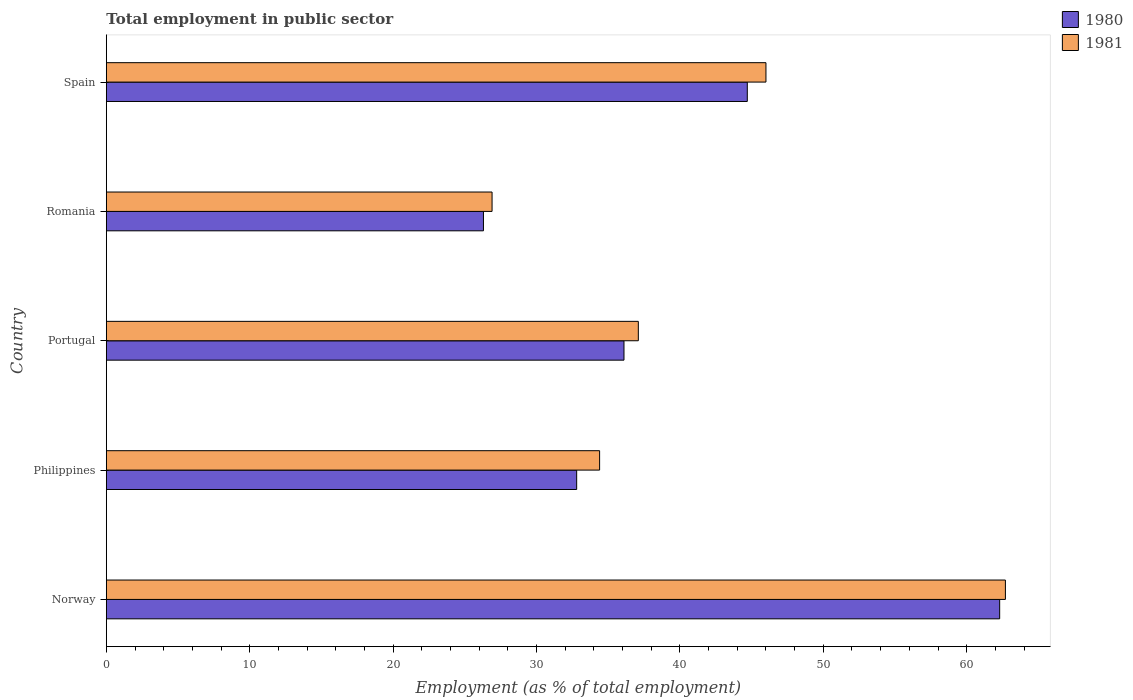How many different coloured bars are there?
Offer a terse response. 2. How many groups of bars are there?
Your answer should be very brief. 5. In how many cases, is the number of bars for a given country not equal to the number of legend labels?
Ensure brevity in your answer.  0. What is the employment in public sector in 1980 in Romania?
Your response must be concise. 26.3. Across all countries, what is the maximum employment in public sector in 1980?
Your answer should be very brief. 62.3. Across all countries, what is the minimum employment in public sector in 1980?
Offer a very short reply. 26.3. In which country was the employment in public sector in 1980 maximum?
Your response must be concise. Norway. In which country was the employment in public sector in 1980 minimum?
Give a very brief answer. Romania. What is the total employment in public sector in 1980 in the graph?
Ensure brevity in your answer.  202.2. What is the difference between the employment in public sector in 1980 in Portugal and that in Romania?
Offer a terse response. 9.8. What is the difference between the employment in public sector in 1980 in Spain and the employment in public sector in 1981 in Romania?
Your response must be concise. 17.8. What is the average employment in public sector in 1980 per country?
Give a very brief answer. 40.44. What is the difference between the employment in public sector in 1981 and employment in public sector in 1980 in Philippines?
Provide a succinct answer. 1.6. In how many countries, is the employment in public sector in 1980 greater than 34 %?
Keep it short and to the point. 3. What is the ratio of the employment in public sector in 1981 in Norway to that in Spain?
Provide a succinct answer. 1.36. Is the employment in public sector in 1981 in Philippines less than that in Romania?
Ensure brevity in your answer.  No. What is the difference between the highest and the second highest employment in public sector in 1980?
Your response must be concise. 17.6. What is the difference between the highest and the lowest employment in public sector in 1980?
Keep it short and to the point. 36. In how many countries, is the employment in public sector in 1981 greater than the average employment in public sector in 1981 taken over all countries?
Offer a terse response. 2. How many countries are there in the graph?
Your answer should be very brief. 5. Does the graph contain grids?
Your response must be concise. No. How are the legend labels stacked?
Make the answer very short. Vertical. What is the title of the graph?
Provide a short and direct response. Total employment in public sector. Does "1980" appear as one of the legend labels in the graph?
Provide a short and direct response. Yes. What is the label or title of the X-axis?
Provide a succinct answer. Employment (as % of total employment). What is the label or title of the Y-axis?
Your response must be concise. Country. What is the Employment (as % of total employment) in 1980 in Norway?
Your answer should be compact. 62.3. What is the Employment (as % of total employment) in 1981 in Norway?
Ensure brevity in your answer.  62.7. What is the Employment (as % of total employment) of 1980 in Philippines?
Provide a succinct answer. 32.8. What is the Employment (as % of total employment) of 1981 in Philippines?
Offer a terse response. 34.4. What is the Employment (as % of total employment) of 1980 in Portugal?
Make the answer very short. 36.1. What is the Employment (as % of total employment) in 1981 in Portugal?
Your response must be concise. 37.1. What is the Employment (as % of total employment) of 1980 in Romania?
Give a very brief answer. 26.3. What is the Employment (as % of total employment) in 1981 in Romania?
Offer a very short reply. 26.9. What is the Employment (as % of total employment) of 1980 in Spain?
Offer a terse response. 44.7. Across all countries, what is the maximum Employment (as % of total employment) of 1980?
Provide a succinct answer. 62.3. Across all countries, what is the maximum Employment (as % of total employment) in 1981?
Ensure brevity in your answer.  62.7. Across all countries, what is the minimum Employment (as % of total employment) of 1980?
Make the answer very short. 26.3. Across all countries, what is the minimum Employment (as % of total employment) of 1981?
Make the answer very short. 26.9. What is the total Employment (as % of total employment) of 1980 in the graph?
Your answer should be very brief. 202.2. What is the total Employment (as % of total employment) of 1981 in the graph?
Offer a very short reply. 207.1. What is the difference between the Employment (as % of total employment) of 1980 in Norway and that in Philippines?
Provide a succinct answer. 29.5. What is the difference between the Employment (as % of total employment) in 1981 in Norway and that in Philippines?
Your response must be concise. 28.3. What is the difference between the Employment (as % of total employment) of 1980 in Norway and that in Portugal?
Your response must be concise. 26.2. What is the difference between the Employment (as % of total employment) in 1981 in Norway and that in Portugal?
Make the answer very short. 25.6. What is the difference between the Employment (as % of total employment) in 1981 in Norway and that in Romania?
Make the answer very short. 35.8. What is the difference between the Employment (as % of total employment) in 1981 in Norway and that in Spain?
Ensure brevity in your answer.  16.7. What is the difference between the Employment (as % of total employment) in 1980 in Philippines and that in Portugal?
Offer a terse response. -3.3. What is the difference between the Employment (as % of total employment) in 1981 in Philippines and that in Portugal?
Give a very brief answer. -2.7. What is the difference between the Employment (as % of total employment) in 1980 in Philippines and that in Romania?
Your answer should be very brief. 6.5. What is the difference between the Employment (as % of total employment) in 1981 in Philippines and that in Romania?
Your answer should be very brief. 7.5. What is the difference between the Employment (as % of total employment) in 1981 in Philippines and that in Spain?
Offer a terse response. -11.6. What is the difference between the Employment (as % of total employment) in 1981 in Portugal and that in Romania?
Provide a succinct answer. 10.2. What is the difference between the Employment (as % of total employment) of 1980 in Portugal and that in Spain?
Your answer should be compact. -8.6. What is the difference between the Employment (as % of total employment) in 1981 in Portugal and that in Spain?
Your answer should be very brief. -8.9. What is the difference between the Employment (as % of total employment) of 1980 in Romania and that in Spain?
Keep it short and to the point. -18.4. What is the difference between the Employment (as % of total employment) of 1981 in Romania and that in Spain?
Make the answer very short. -19.1. What is the difference between the Employment (as % of total employment) in 1980 in Norway and the Employment (as % of total employment) in 1981 in Philippines?
Your response must be concise. 27.9. What is the difference between the Employment (as % of total employment) of 1980 in Norway and the Employment (as % of total employment) of 1981 in Portugal?
Offer a terse response. 25.2. What is the difference between the Employment (as % of total employment) of 1980 in Norway and the Employment (as % of total employment) of 1981 in Romania?
Your answer should be very brief. 35.4. What is the difference between the Employment (as % of total employment) in 1980 in Philippines and the Employment (as % of total employment) in 1981 in Romania?
Ensure brevity in your answer.  5.9. What is the difference between the Employment (as % of total employment) of 1980 in Philippines and the Employment (as % of total employment) of 1981 in Spain?
Give a very brief answer. -13.2. What is the difference between the Employment (as % of total employment) of 1980 in Portugal and the Employment (as % of total employment) of 1981 in Romania?
Give a very brief answer. 9.2. What is the difference between the Employment (as % of total employment) in 1980 in Portugal and the Employment (as % of total employment) in 1981 in Spain?
Keep it short and to the point. -9.9. What is the difference between the Employment (as % of total employment) of 1980 in Romania and the Employment (as % of total employment) of 1981 in Spain?
Make the answer very short. -19.7. What is the average Employment (as % of total employment) of 1980 per country?
Provide a short and direct response. 40.44. What is the average Employment (as % of total employment) in 1981 per country?
Make the answer very short. 41.42. What is the difference between the Employment (as % of total employment) of 1980 and Employment (as % of total employment) of 1981 in Norway?
Offer a terse response. -0.4. What is the difference between the Employment (as % of total employment) of 1980 and Employment (as % of total employment) of 1981 in Spain?
Your answer should be compact. -1.3. What is the ratio of the Employment (as % of total employment) in 1980 in Norway to that in Philippines?
Give a very brief answer. 1.9. What is the ratio of the Employment (as % of total employment) of 1981 in Norway to that in Philippines?
Your response must be concise. 1.82. What is the ratio of the Employment (as % of total employment) of 1980 in Norway to that in Portugal?
Ensure brevity in your answer.  1.73. What is the ratio of the Employment (as % of total employment) of 1981 in Norway to that in Portugal?
Offer a terse response. 1.69. What is the ratio of the Employment (as % of total employment) of 1980 in Norway to that in Romania?
Make the answer very short. 2.37. What is the ratio of the Employment (as % of total employment) of 1981 in Norway to that in Romania?
Your response must be concise. 2.33. What is the ratio of the Employment (as % of total employment) of 1980 in Norway to that in Spain?
Give a very brief answer. 1.39. What is the ratio of the Employment (as % of total employment) in 1981 in Norway to that in Spain?
Give a very brief answer. 1.36. What is the ratio of the Employment (as % of total employment) of 1980 in Philippines to that in Portugal?
Your answer should be very brief. 0.91. What is the ratio of the Employment (as % of total employment) in 1981 in Philippines to that in Portugal?
Your response must be concise. 0.93. What is the ratio of the Employment (as % of total employment) in 1980 in Philippines to that in Romania?
Provide a succinct answer. 1.25. What is the ratio of the Employment (as % of total employment) in 1981 in Philippines to that in Romania?
Keep it short and to the point. 1.28. What is the ratio of the Employment (as % of total employment) in 1980 in Philippines to that in Spain?
Offer a terse response. 0.73. What is the ratio of the Employment (as % of total employment) of 1981 in Philippines to that in Spain?
Your answer should be compact. 0.75. What is the ratio of the Employment (as % of total employment) of 1980 in Portugal to that in Romania?
Your answer should be compact. 1.37. What is the ratio of the Employment (as % of total employment) of 1981 in Portugal to that in Romania?
Offer a terse response. 1.38. What is the ratio of the Employment (as % of total employment) in 1980 in Portugal to that in Spain?
Your answer should be very brief. 0.81. What is the ratio of the Employment (as % of total employment) in 1981 in Portugal to that in Spain?
Offer a terse response. 0.81. What is the ratio of the Employment (as % of total employment) in 1980 in Romania to that in Spain?
Keep it short and to the point. 0.59. What is the ratio of the Employment (as % of total employment) of 1981 in Romania to that in Spain?
Provide a short and direct response. 0.58. What is the difference between the highest and the second highest Employment (as % of total employment) in 1980?
Your answer should be very brief. 17.6. What is the difference between the highest and the second highest Employment (as % of total employment) of 1981?
Provide a succinct answer. 16.7. What is the difference between the highest and the lowest Employment (as % of total employment) in 1981?
Give a very brief answer. 35.8. 